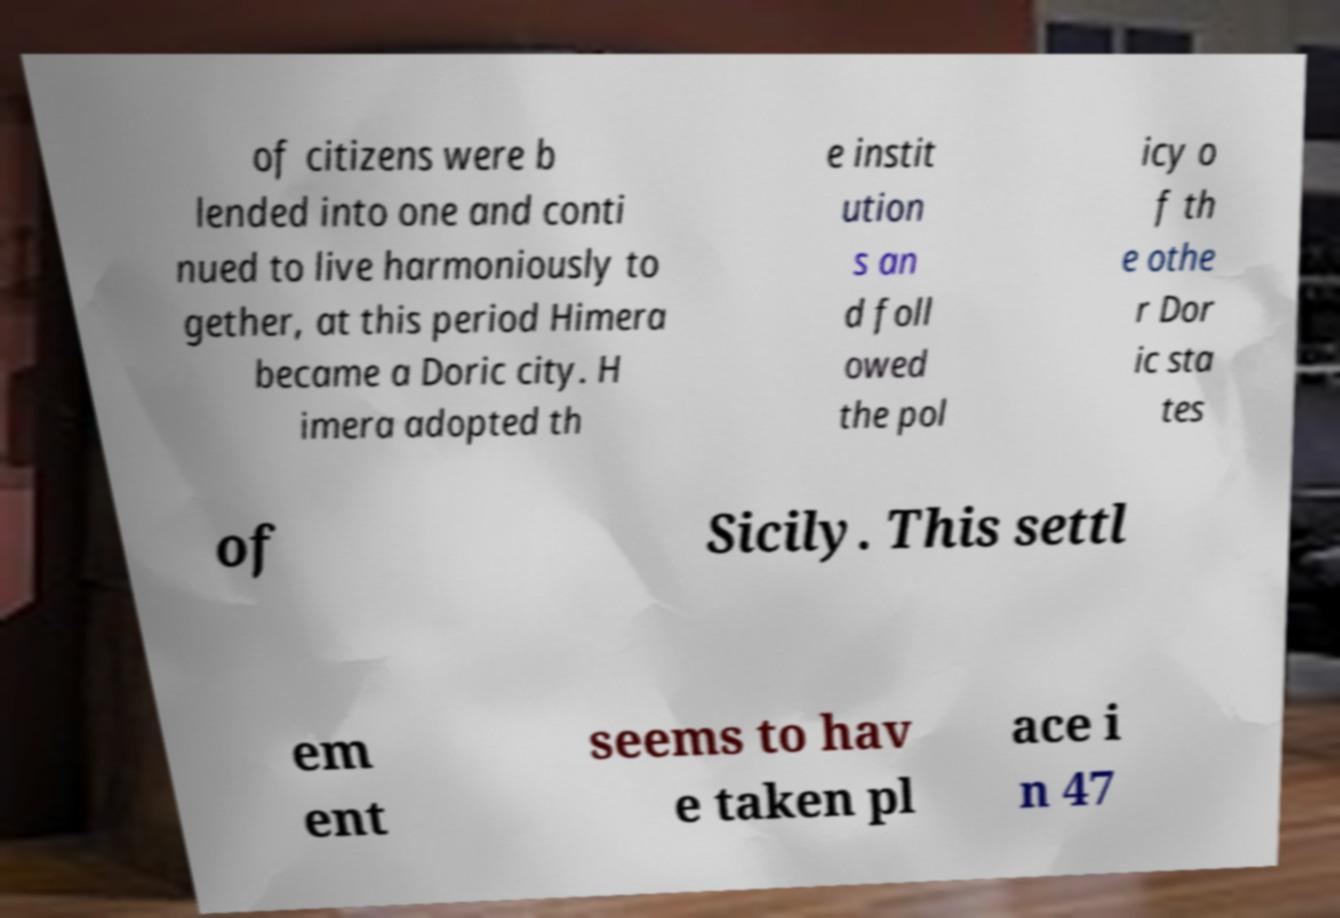For documentation purposes, I need the text within this image transcribed. Could you provide that? of citizens were b lended into one and conti nued to live harmoniously to gether, at this period Himera became a Doric city. H imera adopted th e instit ution s an d foll owed the pol icy o f th e othe r Dor ic sta tes of Sicily. This settl em ent seems to hav e taken pl ace i n 47 